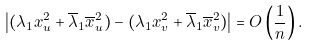Convert formula to latex. <formula><loc_0><loc_0><loc_500><loc_500>\left | ( \lambda _ { 1 } x _ { u } ^ { 2 } + \overline { \lambda } _ { 1 } \overline { x } _ { u } ^ { 2 } ) - ( \lambda _ { 1 } x _ { v } ^ { 2 } + \overline { \lambda } _ { 1 } \overline { x } _ { v } ^ { 2 } ) \right | = O \left ( \frac { 1 } { n } \right ) .</formula> 